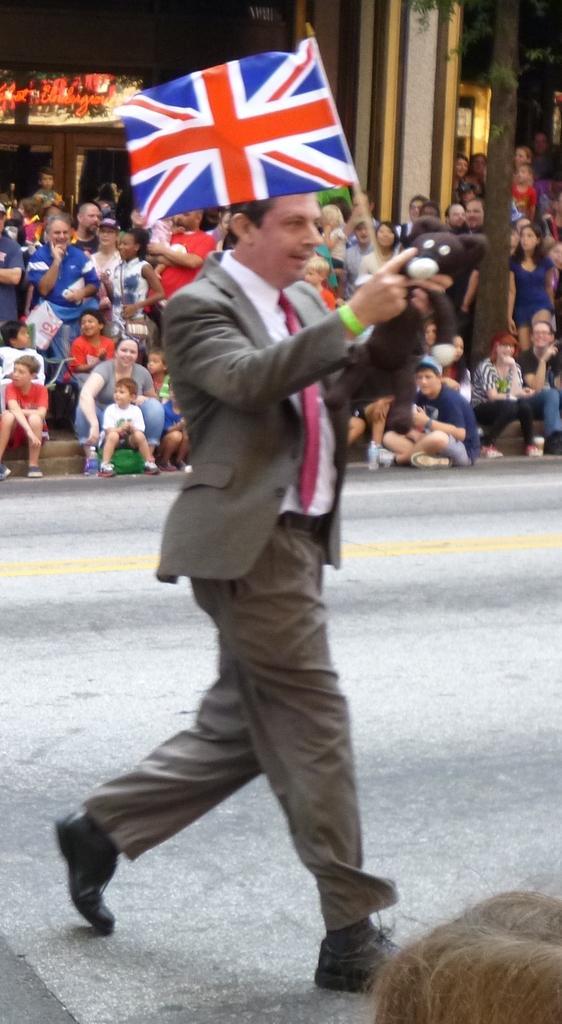Could you give a brief overview of what you see in this image? In the center of the image we can see a man walking with a flag and teddy bear. In the background there is a crowd and building. 